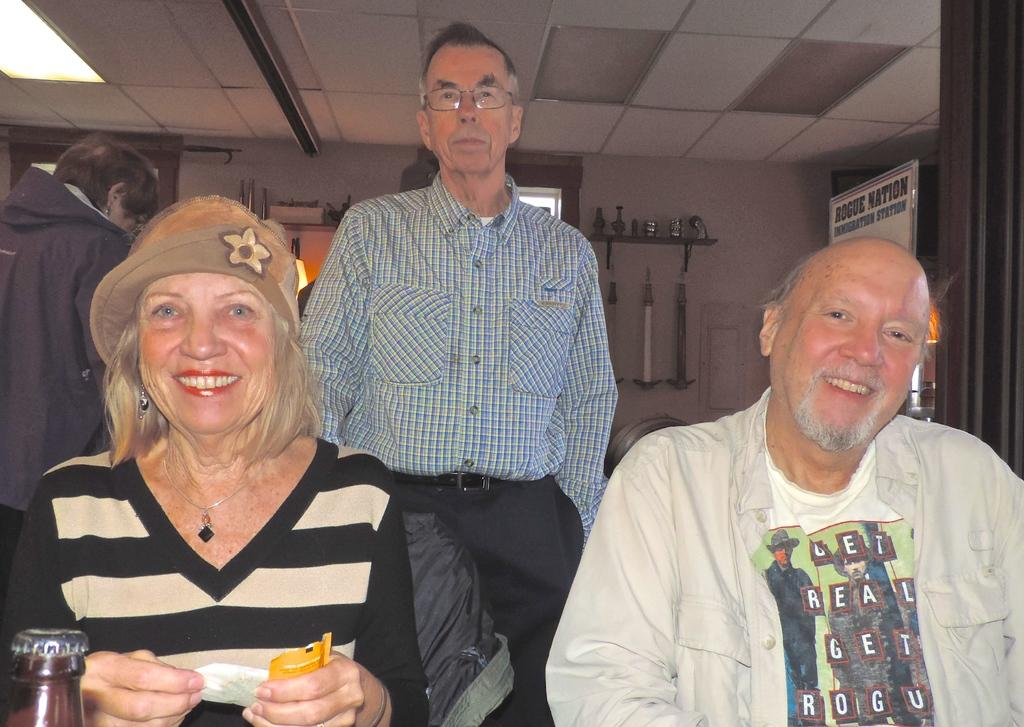<image>
Describe the image concisely. 3 elderly people are posing for the picture in an office that has a sign that reads Rogue Nation. 